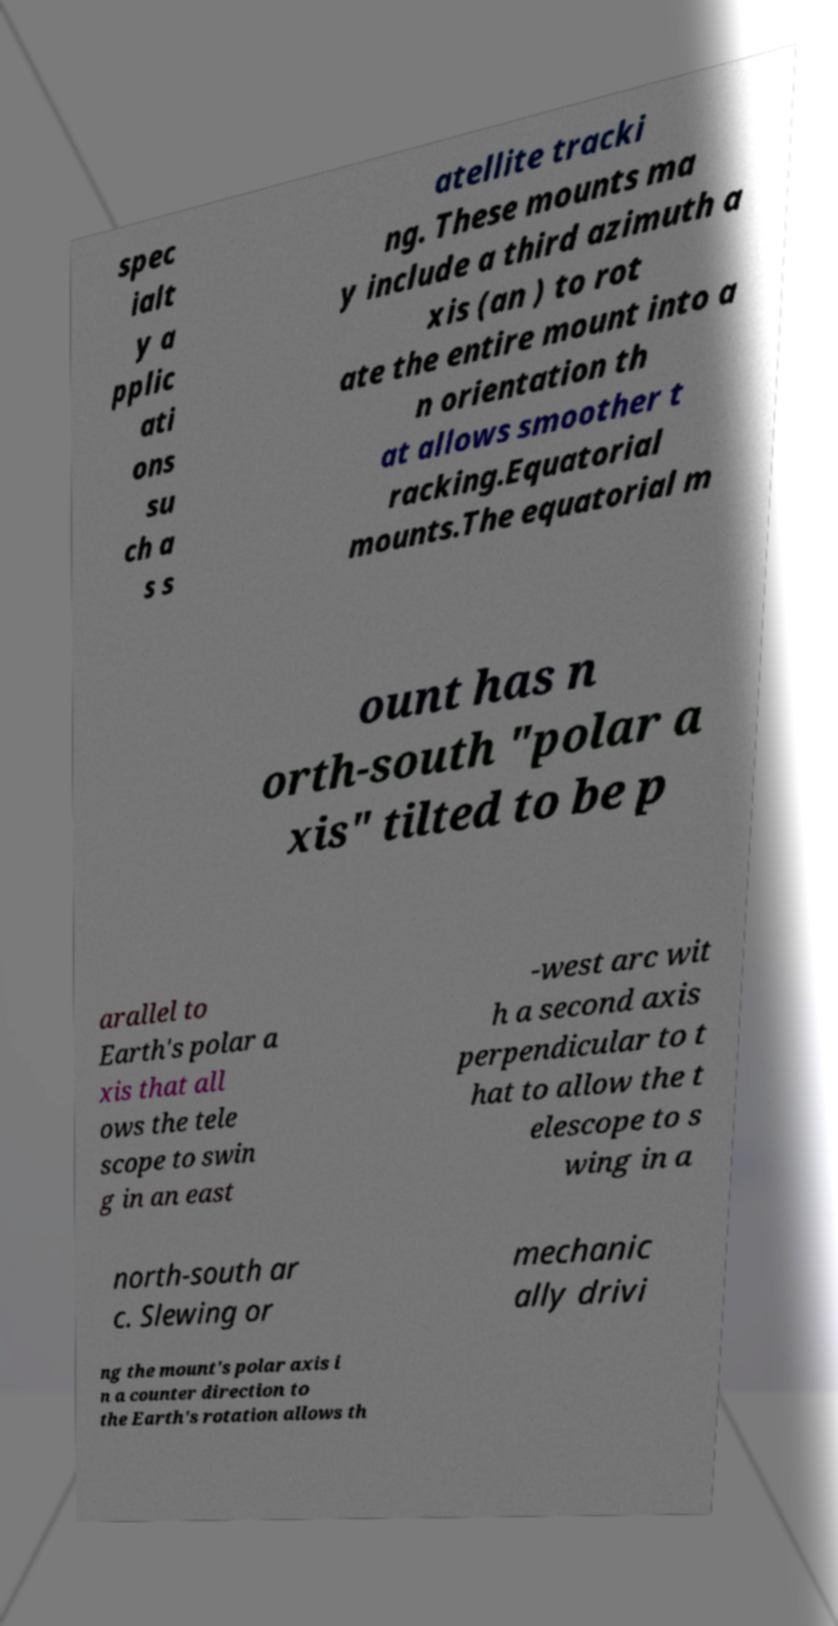Can you accurately transcribe the text from the provided image for me? spec ialt y a pplic ati ons su ch a s s atellite tracki ng. These mounts ma y include a third azimuth a xis (an ) to rot ate the entire mount into a n orientation th at allows smoother t racking.Equatorial mounts.The equatorial m ount has n orth-south "polar a xis" tilted to be p arallel to Earth's polar a xis that all ows the tele scope to swin g in an east -west arc wit h a second axis perpendicular to t hat to allow the t elescope to s wing in a north-south ar c. Slewing or mechanic ally drivi ng the mount's polar axis i n a counter direction to the Earth's rotation allows th 